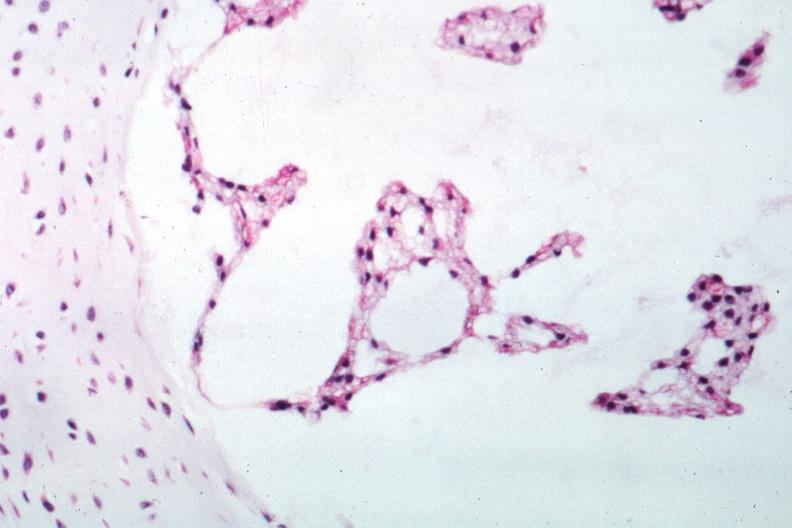s liver present?
Answer the question using a single word or phrase. No 